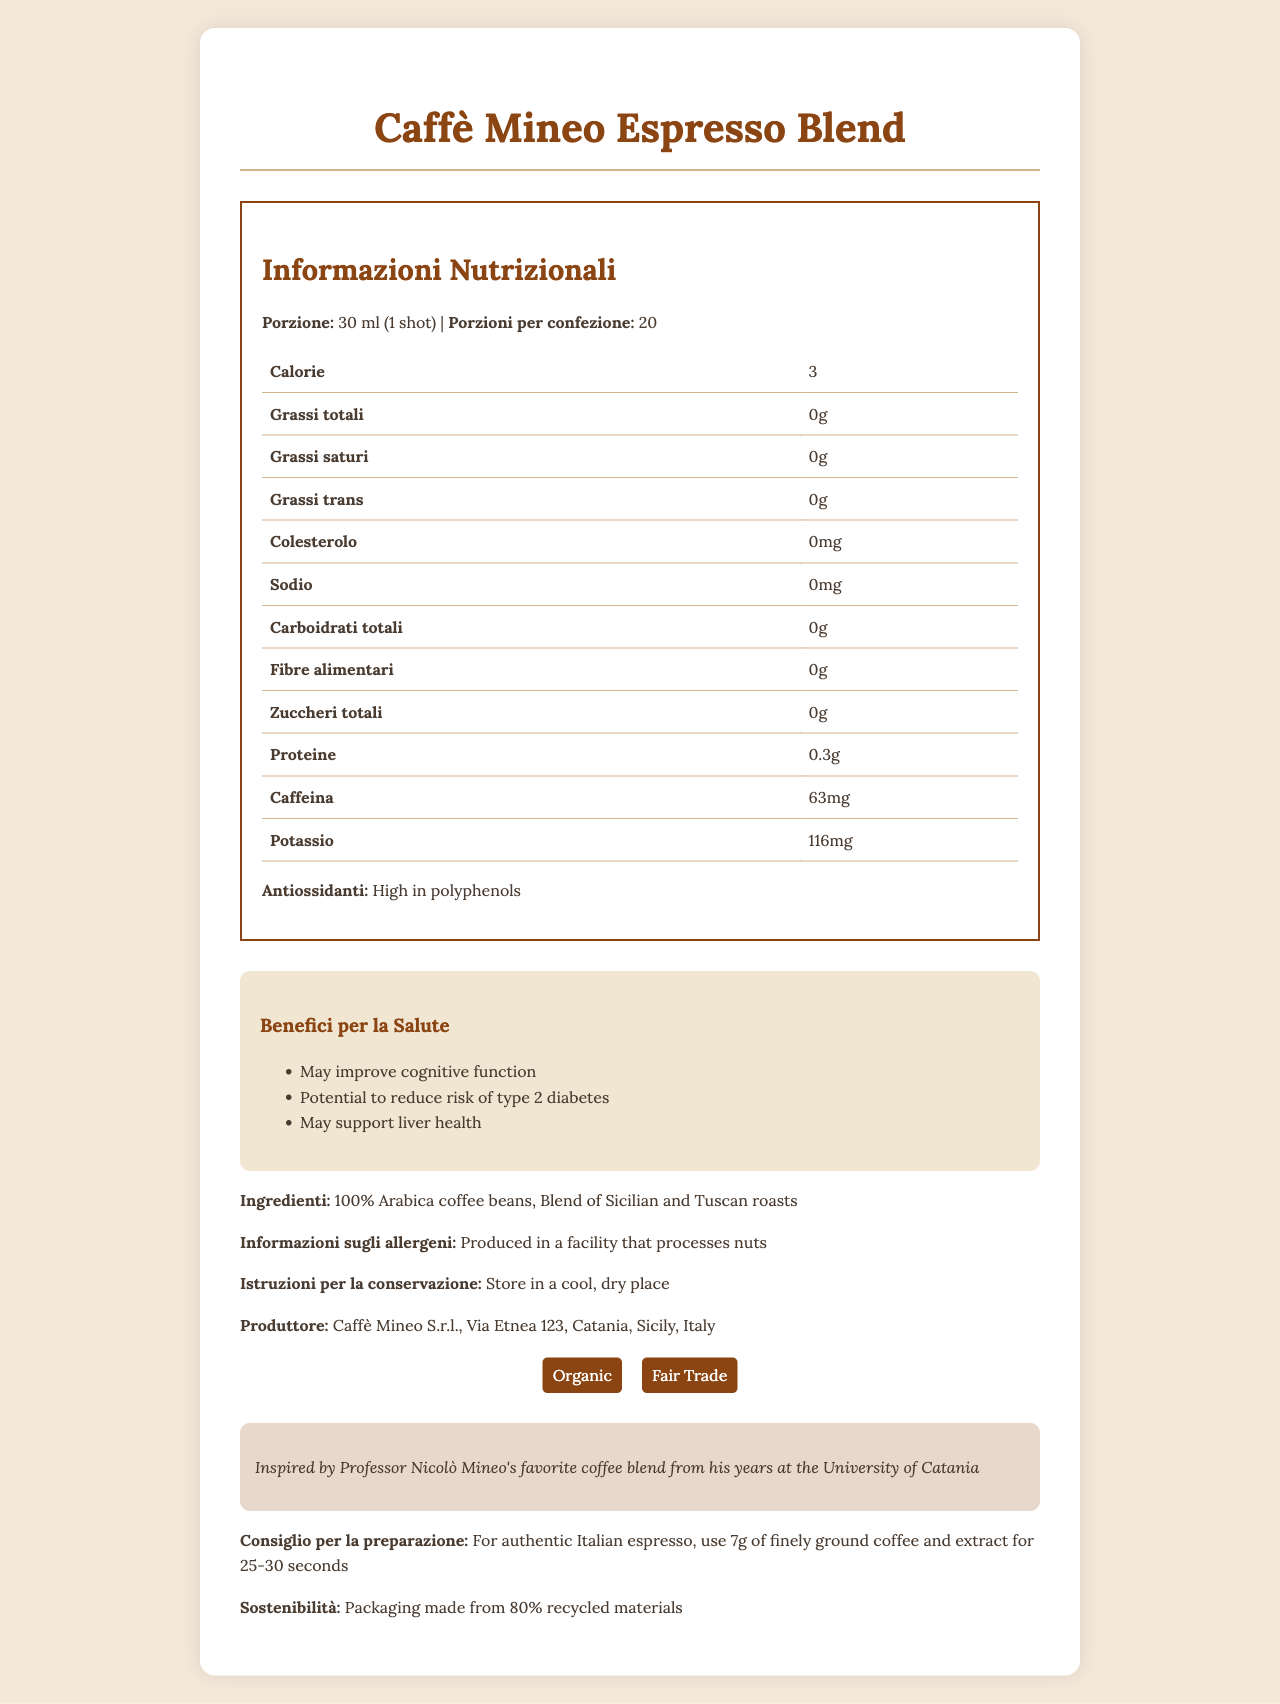what is the product name? The product name is displayed at the top of the document in large font.
Answer: Caffè Mineo Espresso Blend what is the serving size? The serving size is noted as "30 ml (1 shot)" in the nutrition information section.
Answer: 30 ml (1 shot) how many calories are in one serving? The calorie content per serving is listed as 3 in the table under the nutrition information section.
Answer: 3 how much caffeine is in one shot of this espresso blend? The caffeine content per serving is specified as 63 mg in the nutrition information table.
Answer: 63 mg what is the amount of potassium per serving? The potassium content is listed as 116 mg in the table under the nutrition information section.
Answer: 116 mg what are the main ingredients of this espresso blend? The main ingredients are mentioned under the ingredients section as "100% Arabica coffee beans, Blend of Sicilian and Tuscan roasts."
Answer: 100% Arabica coffee beans, Blend of Sicilian and Tuscan roasts what are the potential health benefits of this espresso blend? The health benefits section lists these specific benefits.
Answer: May improve cognitive function, Potential to reduce risk of type 2 diabetes, May support liver health how many servings are there per container? The servings per container are stated as 20 in the nutrition information section.
Answer: 20 how much protein is in each serving? The protein content per serving is listed as 0.3g in the nutrition information table.
Answer: 0.3g what certification labels are associated with this product? A. Organic B. Fair Trade C. Non-GMO D. Kosher The document lists the certifications as "Organic" and "Fair Trade" under the certifications section.
Answer: A and B what is the recommended brewing method for an authentic Italian espresso? A. Use 10g of coarsely ground coffee B. Use 7g of finely ground coffee and extract for 25-30 seconds C. Use 5g of finely ground coffee and extract for 15-20 seconds The brewing tip provided in the document suggests using 7g of finely ground coffee and extracting for 25-30 seconds.
Answer: B is this product high in antioxidants? The document explicitly mentions that the product is "High in polyphenols" under the nutrition information section.
Answer: Yes does the cultural note provide any historical background about the coffee blend? The cultural note states that the coffee blend is inspired by Professor Nicolò Mineo's favorite coffee blend from his years at the University of Catania.
Answer: Yes summarize the main idea of the document. The document is designed to inform consumers about the nutritional content, potential health benefits, and cultural significance of the Caffè Mineo Espresso Blend. It also provides practical information about the ingredients, allergens, storage, preparation, and environmental impact.
Answer: The document provides comprehensive information about the Caffè Mineo Espresso Blend, including nutrition facts, health benefits, ingredients, allergen information, storage instructions, manufacturer details, certifications, cultural notes, brewing tips, and sustainability information. how much total fat does each serving contain? The total fat content per serving is listed as 0g in the nutrition information table.
Answer: 0g what type of packaging materials is used for this product? The sustainability information section mentions that the packaging is made from 80% recycled materials.
Answer: 80% recycled materials what is the street address of the manufacturer? The manufacturer information section provides the address as Via Etnea 123, Catania, Sicily, Italy.
Answer: Via Etnea 123, Catania, Sicily, Italy how is this product related to Professor Nicolò Mineo? The cultural note mentions the inspiration behind the blend.
Answer: The espresso blend is inspired by Professor Nicolò Mineo's favorite coffee blend from his years at the University of Catania. What percentage of vitamin A does this product contain? The Vitamin A content is listed as 0% in the nutritional information section.
Answer: 0% What facility process information is provided about allergens? The allergen information section mentions that the product is produced in a facility that processes nuts.
Answer: Produced in a facility that processes nuts How can storing instructions affect the quality of the coffee? Storing the coffee in a cool, dry place helps maintain its quality over time.
Answer: It is recommended to store in a cool, dry place to maintain freshness and flavor. How long should each shot of coffee be extracted for optimal taste? The brewing tip section recommends extracting for 25-30 seconds for authentic Italian espresso.
Answer: 25-30 seconds what is the net weight of each pack? The document does not provide information about the net weight of each pack.
Answer: Not indicated 